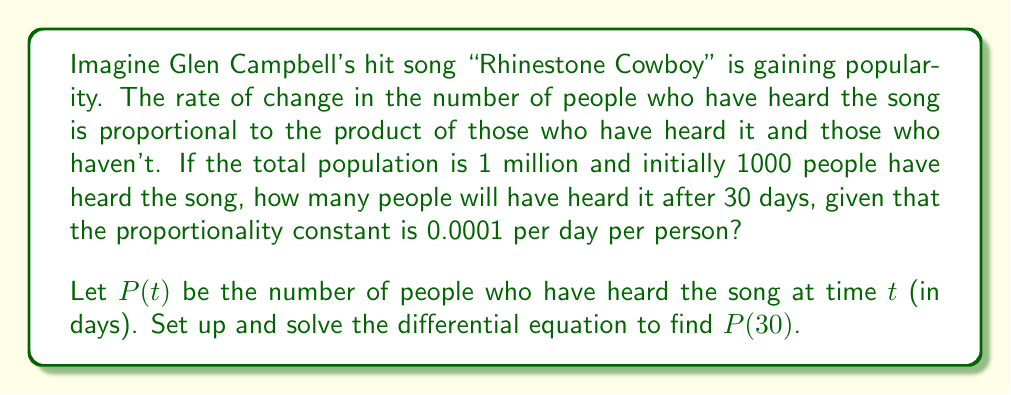Help me with this question. Let's approach this step-by-step:

1) The differential equation for this logistic growth model is:

   $$\frac{dP}{dt} = kP(N-P)$$

   where $k$ is the proportionality constant, $N$ is the total population.

2) Given:
   - $N = 1,000,000$
   - $P(0) = 1,000$
   - $k = 0.0001$

3) Substituting these values into the equation:

   $$\frac{dP}{dt} = 0.0001P(1,000,000-P)$$

4) This is a separable differential equation. Rearranging:

   $$\frac{dP}{P(1,000,000-P)} = 0.0001dt$$

5) Integrating both sides:

   $$\int \frac{dP}{P(1,000,000-P)} = \int 0.0001dt$$

6) The left side integrates to:

   $$\frac{1}{1,000,000}\ln\left|\frac{P}{1,000,000-P}\right| = 0.0001t + C$$

7) Using the initial condition $P(0) = 1,000$ to solve for $C$:

   $$C = \frac{1}{1,000,000}\ln\left|\frac{1,000}{999,000}\right| \approx -6.907$$

8) The solution is:

   $$\frac{1}{1,000,000}\ln\left|\frac{P}{1,000,000-P}\right| = 0.0001t - 6.907$$

9) To find $P(30)$, substitute $t=30$:

   $$\frac{1}{1,000,000}\ln\left|\frac{P(30)}{1,000,000-P(30)}\right| = 0.0001(30) - 6.907$$

10) Solving for $P(30)$:

    $$P(30) = \frac{1,000,000}{1 + e^{6.904}} \approx 1,010$$
Answer: 1,010 people 